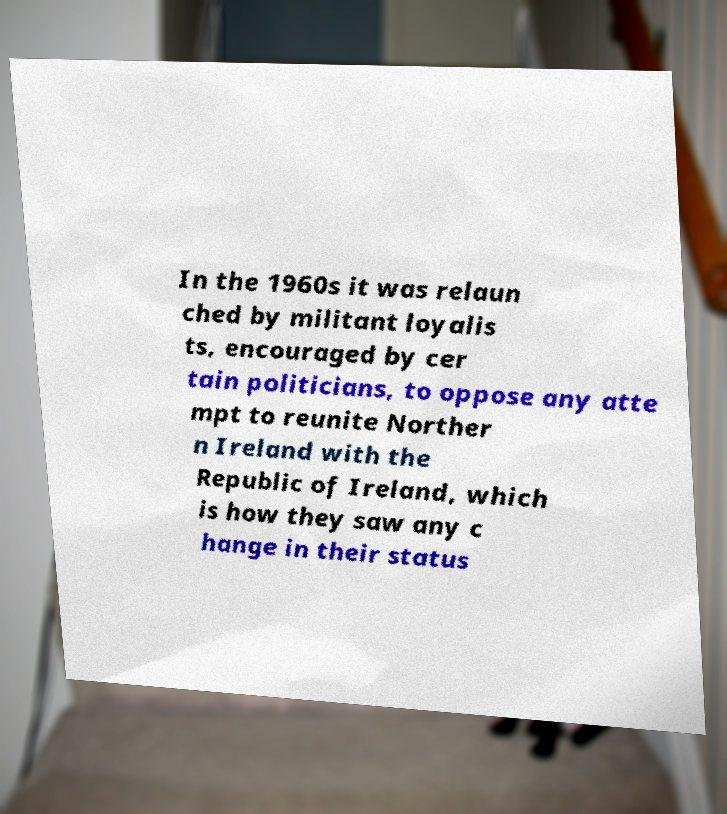Please identify and transcribe the text found in this image. In the 1960s it was relaun ched by militant loyalis ts, encouraged by cer tain politicians, to oppose any atte mpt to reunite Norther n Ireland with the Republic of Ireland, which is how they saw any c hange in their status 